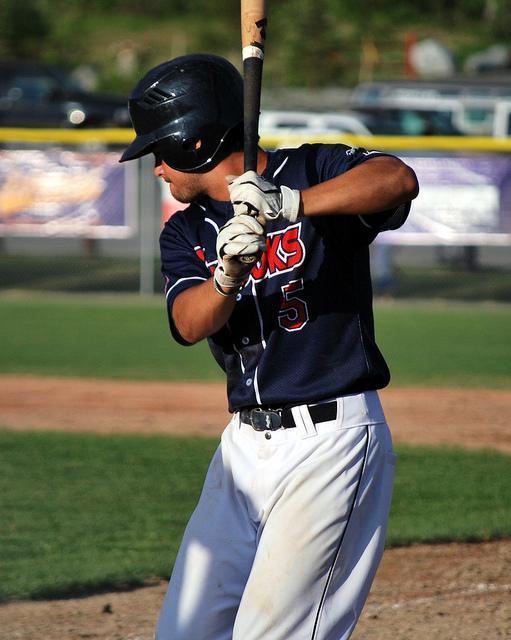How many cars can you see?
Give a very brief answer. 2. 